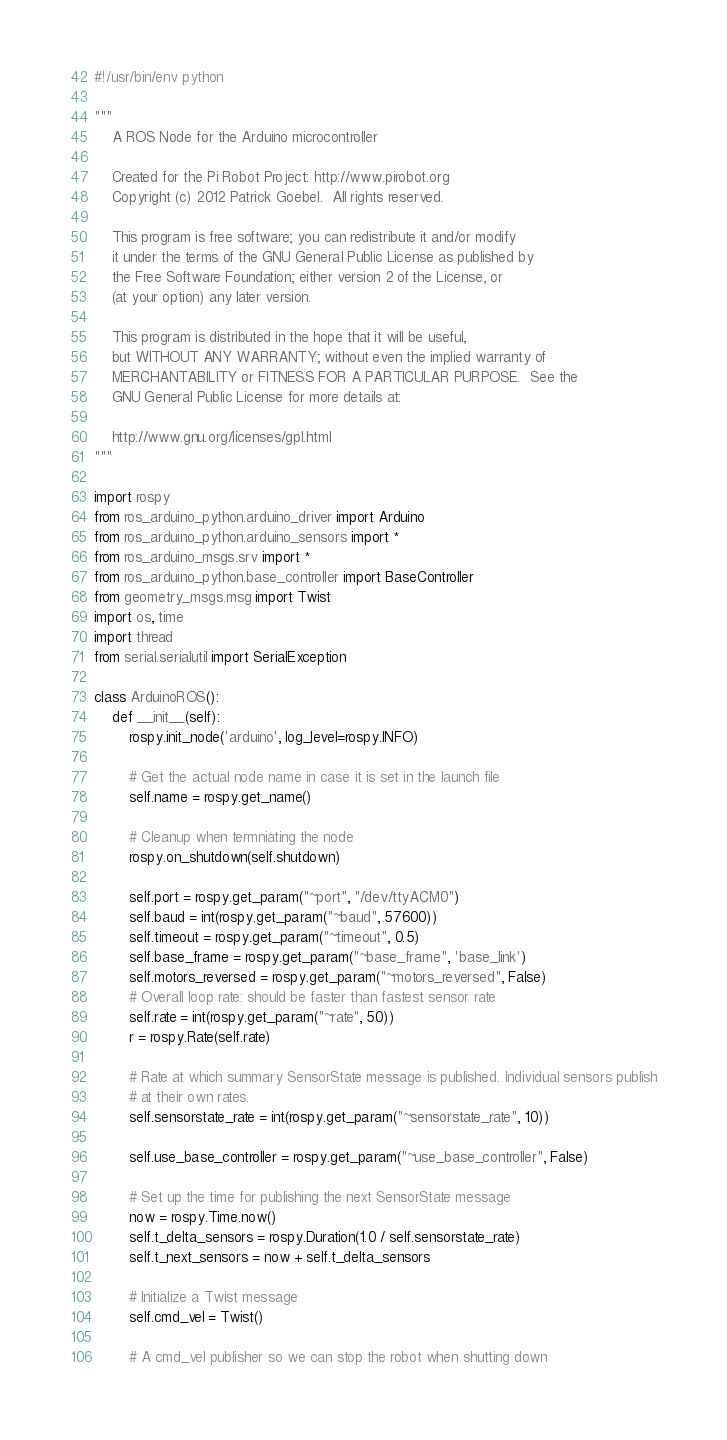Convert code to text. <code><loc_0><loc_0><loc_500><loc_500><_Python_>#!/usr/bin/env python

"""
    A ROS Node for the Arduino microcontroller

    Created for the Pi Robot Project: http://www.pirobot.org
    Copyright (c) 2012 Patrick Goebel.  All rights reserved.

    This program is free software; you can redistribute it and/or modify
    it under the terms of the GNU General Public License as published by
    the Free Software Foundation; either version 2 of the License, or
    (at your option) any later version.

    This program is distributed in the hope that it will be useful,
    but WITHOUT ANY WARRANTY; without even the implied warranty of
    MERCHANTABILITY or FITNESS FOR A PARTICULAR PURPOSE.  See the
    GNU General Public License for more details at:

    http://www.gnu.org/licenses/gpl.html
"""

import rospy
from ros_arduino_python.arduino_driver import Arduino
from ros_arduino_python.arduino_sensors import *
from ros_arduino_msgs.srv import *
from ros_arduino_python.base_controller import BaseController
from geometry_msgs.msg import Twist
import os, time
import thread
from serial.serialutil import SerialException

class ArduinoROS():
    def __init__(self):
        rospy.init_node('arduino', log_level=rospy.INFO)

        # Get the actual node name in case it is set in the launch file
        self.name = rospy.get_name()

        # Cleanup when termniating the node
        rospy.on_shutdown(self.shutdown)

        self.port = rospy.get_param("~port", "/dev/ttyACM0")
        self.baud = int(rospy.get_param("~baud", 57600))
        self.timeout = rospy.get_param("~timeout", 0.5)
        self.base_frame = rospy.get_param("~base_frame", 'base_link')
        self.motors_reversed = rospy.get_param("~motors_reversed", False)
        # Overall loop rate: should be faster than fastest sensor rate
        self.rate = int(rospy.get_param("~rate", 50))
        r = rospy.Rate(self.rate)

        # Rate at which summary SensorState message is published. Individual sensors publish
        # at their own rates.
        self.sensorstate_rate = int(rospy.get_param("~sensorstate_rate", 10))

        self.use_base_controller = rospy.get_param("~use_base_controller", False)

        # Set up the time for publishing the next SensorState message
        now = rospy.Time.now()
        self.t_delta_sensors = rospy.Duration(1.0 / self.sensorstate_rate)
        self.t_next_sensors = now + self.t_delta_sensors

        # Initialize a Twist message
        self.cmd_vel = Twist()

        # A cmd_vel publisher so we can stop the robot when shutting down</code> 